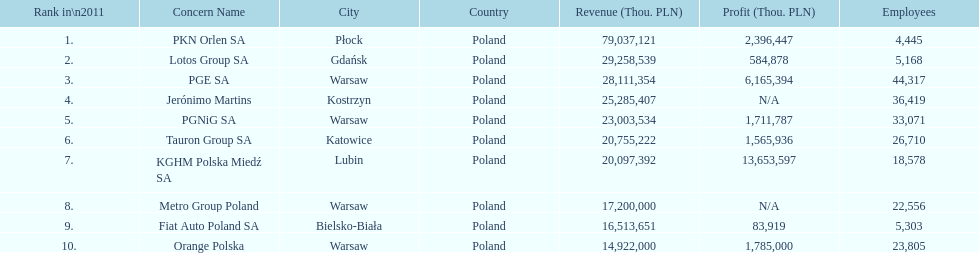Which company had the most revenue? PKN Orlen SA. 